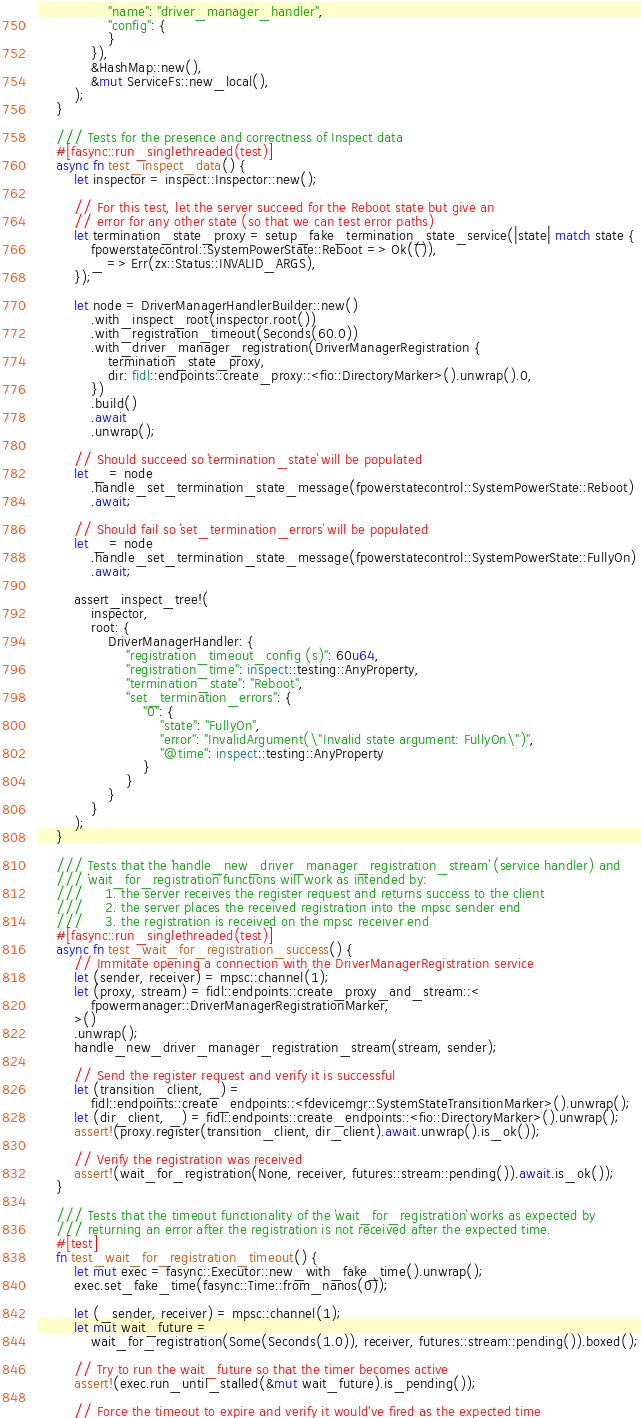Convert code to text. <code><loc_0><loc_0><loc_500><loc_500><_Rust_>                "name": "driver_manager_handler",
                "config": {
                }
            }),
            &HashMap::new(),
            &mut ServiceFs::new_local(),
        );
    }

    /// Tests for the presence and correctness of Inspect data
    #[fasync::run_singlethreaded(test)]
    async fn test_inspect_data() {
        let inspector = inspect::Inspector::new();

        // For this test, let the server succeed for the Reboot state but give an
        // error for any other state (so that we can test error paths)
        let termination_state_proxy = setup_fake_termination_state_service(|state| match state {
            fpowerstatecontrol::SystemPowerState::Reboot => Ok(()),
            _ => Err(zx::Status::INVALID_ARGS),
        });

        let node = DriverManagerHandlerBuilder::new()
            .with_inspect_root(inspector.root())
            .with_registration_timeout(Seconds(60.0))
            .with_driver_manager_registration(DriverManagerRegistration {
                termination_state_proxy,
                dir: fidl::endpoints::create_proxy::<fio::DirectoryMarker>().unwrap().0,
            })
            .build()
            .await
            .unwrap();

        // Should succeed so `termination_state` will be populated
        let _ = node
            .handle_set_termination_state_message(fpowerstatecontrol::SystemPowerState::Reboot)
            .await;

        // Should fail so `set_termination_errors` will be populated
        let _ = node
            .handle_set_termination_state_message(fpowerstatecontrol::SystemPowerState::FullyOn)
            .await;

        assert_inspect_tree!(
            inspector,
            root: {
                DriverManagerHandler: {
                    "registration_timeout_config (s)": 60u64,
                    "registration_time": inspect::testing::AnyProperty,
                    "termination_state": "Reboot",
                    "set_termination_errors": {
                        "0": {
                            "state": "FullyOn",
                            "error": "InvalidArgument(\"Invalid state argument: FullyOn\")",
                            "@time": inspect::testing::AnyProperty
                        }
                    }
                }
            }
        );
    }

    /// Tests that the `handle_new_driver_manager_registration_stream` (service handler) and
    /// `wait_for_registration` functions will work as intended by:
    ///     1. the server receives the register request and returns success to the client
    ///     2. the server places the received registration into the mpsc sender end
    ///     3. the registration is received on the mpsc receiver end
    #[fasync::run_singlethreaded(test)]
    async fn test_wait_for_registration_success() {
        // Immitate opening a connection with the DriverManagerRegistration service
        let (sender, receiver) = mpsc::channel(1);
        let (proxy, stream) = fidl::endpoints::create_proxy_and_stream::<
            fpowermanager::DriverManagerRegistrationMarker,
        >()
        .unwrap();
        handle_new_driver_manager_registration_stream(stream, sender);

        // Send the register request and verify it is successful
        let (transition_client, _) =
            fidl::endpoints::create_endpoints::<fdevicemgr::SystemStateTransitionMarker>().unwrap();
        let (dir_client, _) = fidl::endpoints::create_endpoints::<fio::DirectoryMarker>().unwrap();
        assert!(proxy.register(transition_client, dir_client).await.unwrap().is_ok());

        // Verify the registration was received
        assert!(wait_for_registration(None, receiver, futures::stream::pending()).await.is_ok());
    }

    /// Tests that the timeout functionality of the `wait_for_registration` works as expected by
    /// returning an error after the registration is not received after the expected time.
    #[test]
    fn test_wait_for_registration_timeout() {
        let mut exec = fasync::Executor::new_with_fake_time().unwrap();
        exec.set_fake_time(fasync::Time::from_nanos(0));

        let (_sender, receiver) = mpsc::channel(1);
        let mut wait_future =
            wait_for_registration(Some(Seconds(1.0)), receiver, futures::stream::pending()).boxed();

        // Try to run the wait_future so that the timer becomes active
        assert!(exec.run_until_stalled(&mut wait_future).is_pending());

        // Force the timeout to expire and verify it would've fired as the expected time</code> 